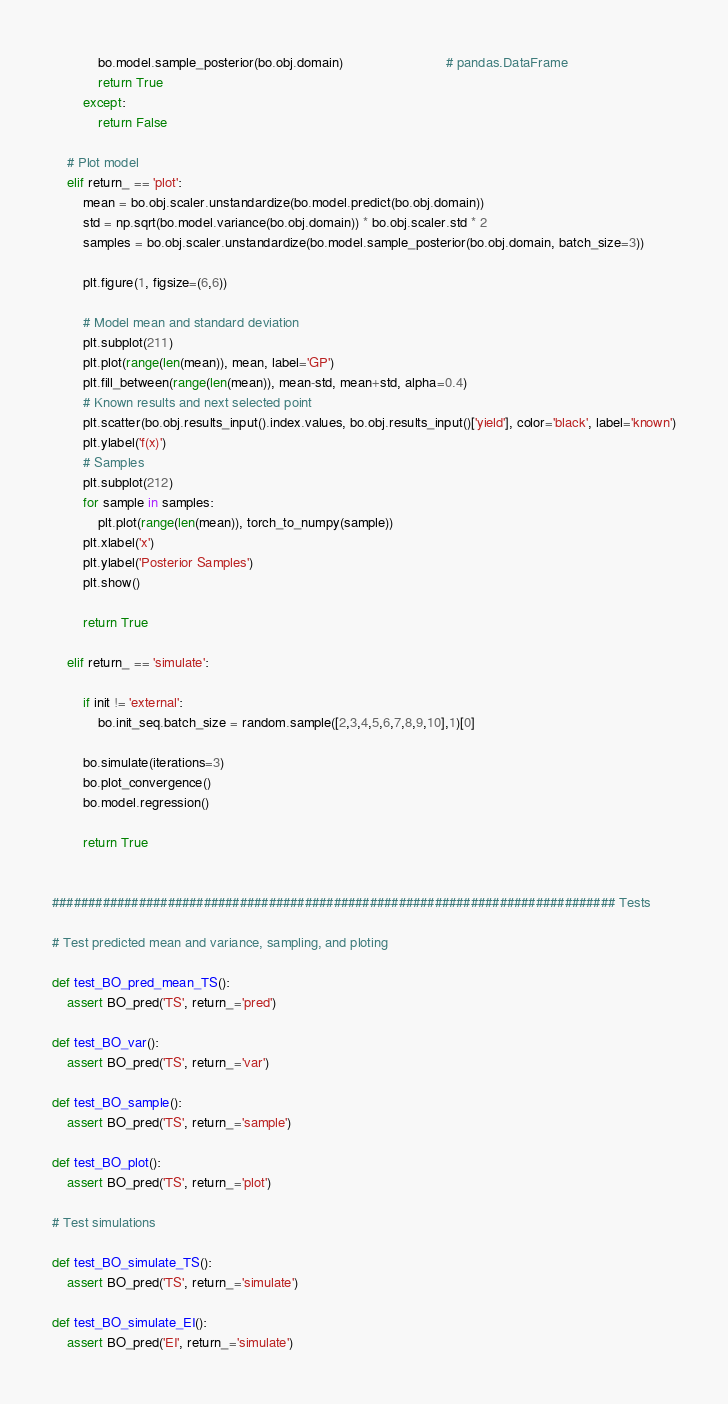<code> <loc_0><loc_0><loc_500><loc_500><_Python_>            bo.model.sample_posterior(bo.obj.domain)                           # pandas.DataFrame
            return True
        except:
            return False
        
    # Plot model
    elif return_ == 'plot':
        mean = bo.obj.scaler.unstandardize(bo.model.predict(bo.obj.domain))
        std = np.sqrt(bo.model.variance(bo.obj.domain)) * bo.obj.scaler.std * 2
        samples = bo.obj.scaler.unstandardize(bo.model.sample_posterior(bo.obj.domain, batch_size=3))

        plt.figure(1, figsize=(6,6))

        # Model mean and standard deviation
        plt.subplot(211)
        plt.plot(range(len(mean)), mean, label='GP')
        plt.fill_between(range(len(mean)), mean-std, mean+std, alpha=0.4)
        # Known results and next selected point
        plt.scatter(bo.obj.results_input().index.values, bo.obj.results_input()['yield'], color='black', label='known')
        plt.ylabel('f(x)')
        # Samples
        plt.subplot(212)
        for sample in samples:
            plt.plot(range(len(mean)), torch_to_numpy(sample))
        plt.xlabel('x')
        plt.ylabel('Posterior Samples')
        plt.show()

        return True
    
    elif return_ == 'simulate':
        
        if init != 'external':
            bo.init_seq.batch_size = random.sample([2,3,4,5,6,7,8,9,10],1)[0]
        
        bo.simulate(iterations=3)
        bo.plot_convergence()
        bo.model.regression()
        
        return True


############################################################################## Tests

# Test predicted mean and variance, sampling, and ploting

def test_BO_pred_mean_TS():
    assert BO_pred('TS', return_='pred')
    
def test_BO_var():
    assert BO_pred('TS', return_='var')

def test_BO_sample():
    assert BO_pred('TS', return_='sample')
    
def test_BO_plot():
    assert BO_pred('TS', return_='plot')
    
# Test simulations

def test_BO_simulate_TS():
    assert BO_pred('TS', return_='simulate')
    
def test_BO_simulate_EI():
    assert BO_pred('EI', return_='simulate')




</code> 